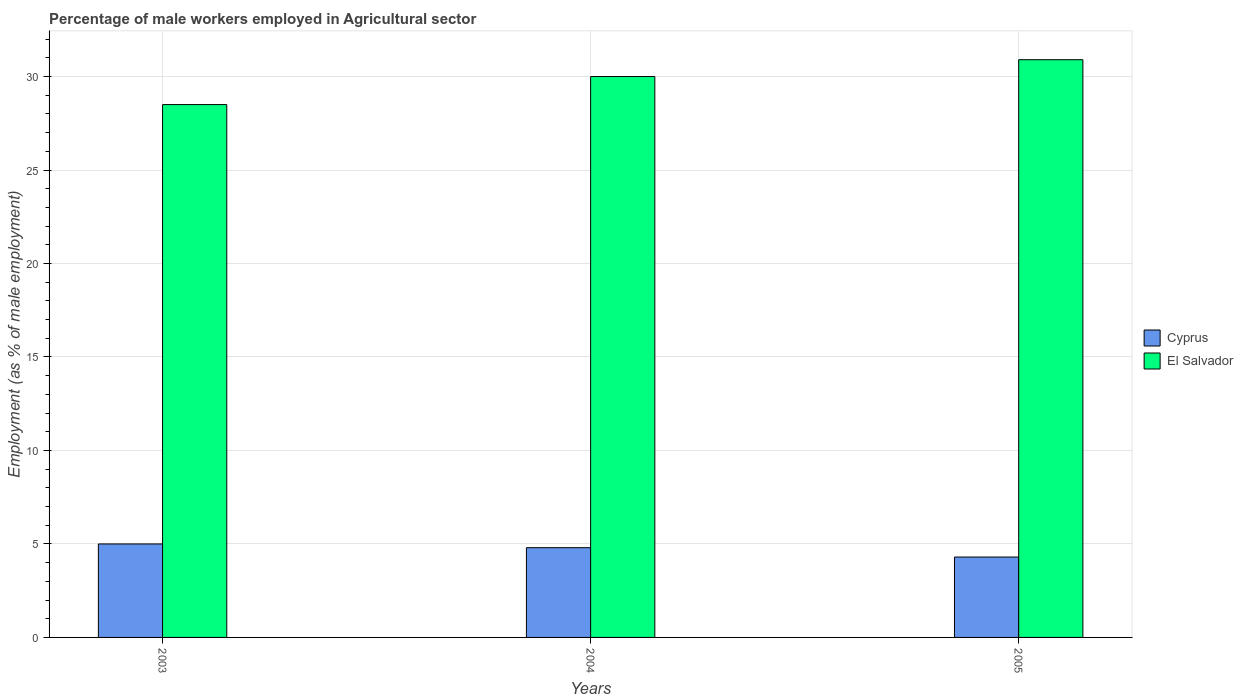How many different coloured bars are there?
Give a very brief answer. 2. How many groups of bars are there?
Your answer should be compact. 3. Are the number of bars per tick equal to the number of legend labels?
Give a very brief answer. Yes. Are the number of bars on each tick of the X-axis equal?
Make the answer very short. Yes. How many bars are there on the 1st tick from the left?
Provide a short and direct response. 2. How many bars are there on the 2nd tick from the right?
Your answer should be very brief. 2. In how many cases, is the number of bars for a given year not equal to the number of legend labels?
Your answer should be compact. 0. What is the percentage of male workers employed in Agricultural sector in El Salvador in 2005?
Give a very brief answer. 30.9. Across all years, what is the maximum percentage of male workers employed in Agricultural sector in El Salvador?
Give a very brief answer. 30.9. Across all years, what is the minimum percentage of male workers employed in Agricultural sector in Cyprus?
Your answer should be very brief. 4.3. In which year was the percentage of male workers employed in Agricultural sector in El Salvador maximum?
Provide a short and direct response. 2005. What is the total percentage of male workers employed in Agricultural sector in El Salvador in the graph?
Your answer should be compact. 89.4. What is the difference between the percentage of male workers employed in Agricultural sector in Cyprus in 2003 and that in 2005?
Make the answer very short. 0.7. What is the difference between the percentage of male workers employed in Agricultural sector in El Salvador in 2005 and the percentage of male workers employed in Agricultural sector in Cyprus in 2003?
Provide a succinct answer. 25.9. What is the average percentage of male workers employed in Agricultural sector in Cyprus per year?
Make the answer very short. 4.7. In the year 2005, what is the difference between the percentage of male workers employed in Agricultural sector in Cyprus and percentage of male workers employed in Agricultural sector in El Salvador?
Your answer should be compact. -26.6. In how many years, is the percentage of male workers employed in Agricultural sector in Cyprus greater than 23 %?
Your answer should be very brief. 0. What is the ratio of the percentage of male workers employed in Agricultural sector in El Salvador in 2003 to that in 2004?
Ensure brevity in your answer.  0.95. What is the difference between the highest and the second highest percentage of male workers employed in Agricultural sector in El Salvador?
Provide a succinct answer. 0.9. What is the difference between the highest and the lowest percentage of male workers employed in Agricultural sector in Cyprus?
Your response must be concise. 0.7. In how many years, is the percentage of male workers employed in Agricultural sector in Cyprus greater than the average percentage of male workers employed in Agricultural sector in Cyprus taken over all years?
Your answer should be very brief. 2. What does the 1st bar from the left in 2003 represents?
Your answer should be compact. Cyprus. What does the 2nd bar from the right in 2005 represents?
Ensure brevity in your answer.  Cyprus. How many years are there in the graph?
Your answer should be compact. 3. What is the difference between two consecutive major ticks on the Y-axis?
Provide a succinct answer. 5. Does the graph contain grids?
Make the answer very short. Yes. How are the legend labels stacked?
Offer a very short reply. Vertical. What is the title of the graph?
Your answer should be very brief. Percentage of male workers employed in Agricultural sector. What is the label or title of the Y-axis?
Your response must be concise. Employment (as % of male employment). What is the Employment (as % of male employment) of Cyprus in 2003?
Ensure brevity in your answer.  5. What is the Employment (as % of male employment) in El Salvador in 2003?
Make the answer very short. 28.5. What is the Employment (as % of male employment) of Cyprus in 2004?
Offer a very short reply. 4.8. What is the Employment (as % of male employment) of Cyprus in 2005?
Offer a very short reply. 4.3. What is the Employment (as % of male employment) of El Salvador in 2005?
Offer a terse response. 30.9. Across all years, what is the maximum Employment (as % of male employment) in El Salvador?
Give a very brief answer. 30.9. Across all years, what is the minimum Employment (as % of male employment) in Cyprus?
Keep it short and to the point. 4.3. What is the total Employment (as % of male employment) in El Salvador in the graph?
Offer a very short reply. 89.4. What is the difference between the Employment (as % of male employment) in Cyprus in 2003 and that in 2004?
Your answer should be compact. 0.2. What is the difference between the Employment (as % of male employment) of El Salvador in 2003 and that in 2004?
Provide a short and direct response. -1.5. What is the difference between the Employment (as % of male employment) of Cyprus in 2003 and that in 2005?
Offer a very short reply. 0.7. What is the difference between the Employment (as % of male employment) in El Salvador in 2003 and that in 2005?
Provide a succinct answer. -2.4. What is the difference between the Employment (as % of male employment) in Cyprus in 2004 and that in 2005?
Keep it short and to the point. 0.5. What is the difference between the Employment (as % of male employment) of El Salvador in 2004 and that in 2005?
Give a very brief answer. -0.9. What is the difference between the Employment (as % of male employment) in Cyprus in 2003 and the Employment (as % of male employment) in El Salvador in 2004?
Ensure brevity in your answer.  -25. What is the difference between the Employment (as % of male employment) of Cyprus in 2003 and the Employment (as % of male employment) of El Salvador in 2005?
Give a very brief answer. -25.9. What is the difference between the Employment (as % of male employment) of Cyprus in 2004 and the Employment (as % of male employment) of El Salvador in 2005?
Your response must be concise. -26.1. What is the average Employment (as % of male employment) in Cyprus per year?
Your answer should be very brief. 4.7. What is the average Employment (as % of male employment) in El Salvador per year?
Give a very brief answer. 29.8. In the year 2003, what is the difference between the Employment (as % of male employment) in Cyprus and Employment (as % of male employment) in El Salvador?
Your answer should be very brief. -23.5. In the year 2004, what is the difference between the Employment (as % of male employment) in Cyprus and Employment (as % of male employment) in El Salvador?
Keep it short and to the point. -25.2. In the year 2005, what is the difference between the Employment (as % of male employment) of Cyprus and Employment (as % of male employment) of El Salvador?
Provide a short and direct response. -26.6. What is the ratio of the Employment (as % of male employment) of Cyprus in 2003 to that in 2004?
Give a very brief answer. 1.04. What is the ratio of the Employment (as % of male employment) of Cyprus in 2003 to that in 2005?
Provide a succinct answer. 1.16. What is the ratio of the Employment (as % of male employment) in El Salvador in 2003 to that in 2005?
Your answer should be very brief. 0.92. What is the ratio of the Employment (as % of male employment) of Cyprus in 2004 to that in 2005?
Offer a terse response. 1.12. What is the ratio of the Employment (as % of male employment) in El Salvador in 2004 to that in 2005?
Offer a terse response. 0.97. 